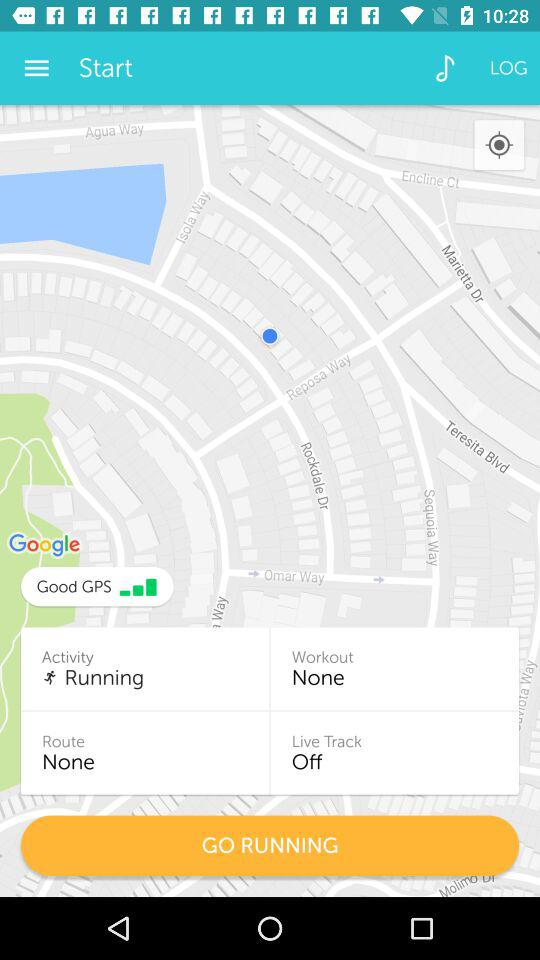What is the workout? The workout is "None". 